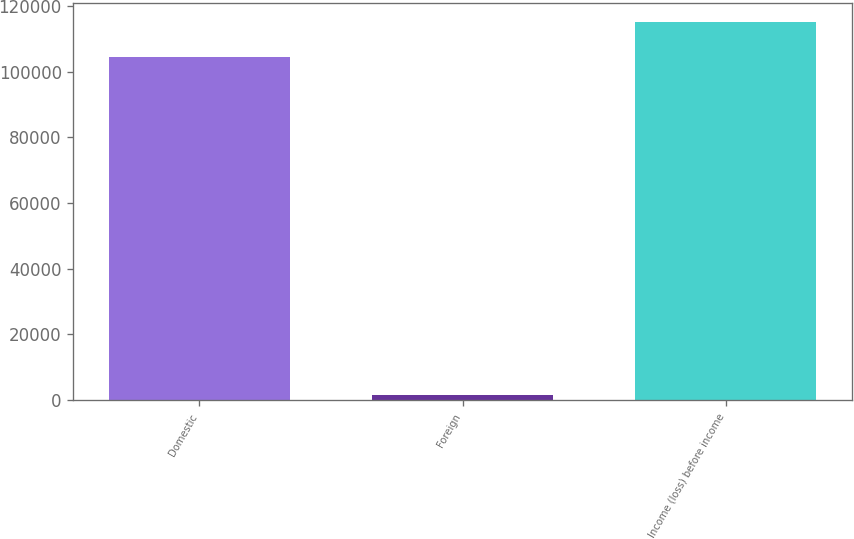Convert chart. <chart><loc_0><loc_0><loc_500><loc_500><bar_chart><fcel>Domestic<fcel>Foreign<fcel>Income (loss) before income<nl><fcel>104556<fcel>1706<fcel>115012<nl></chart> 